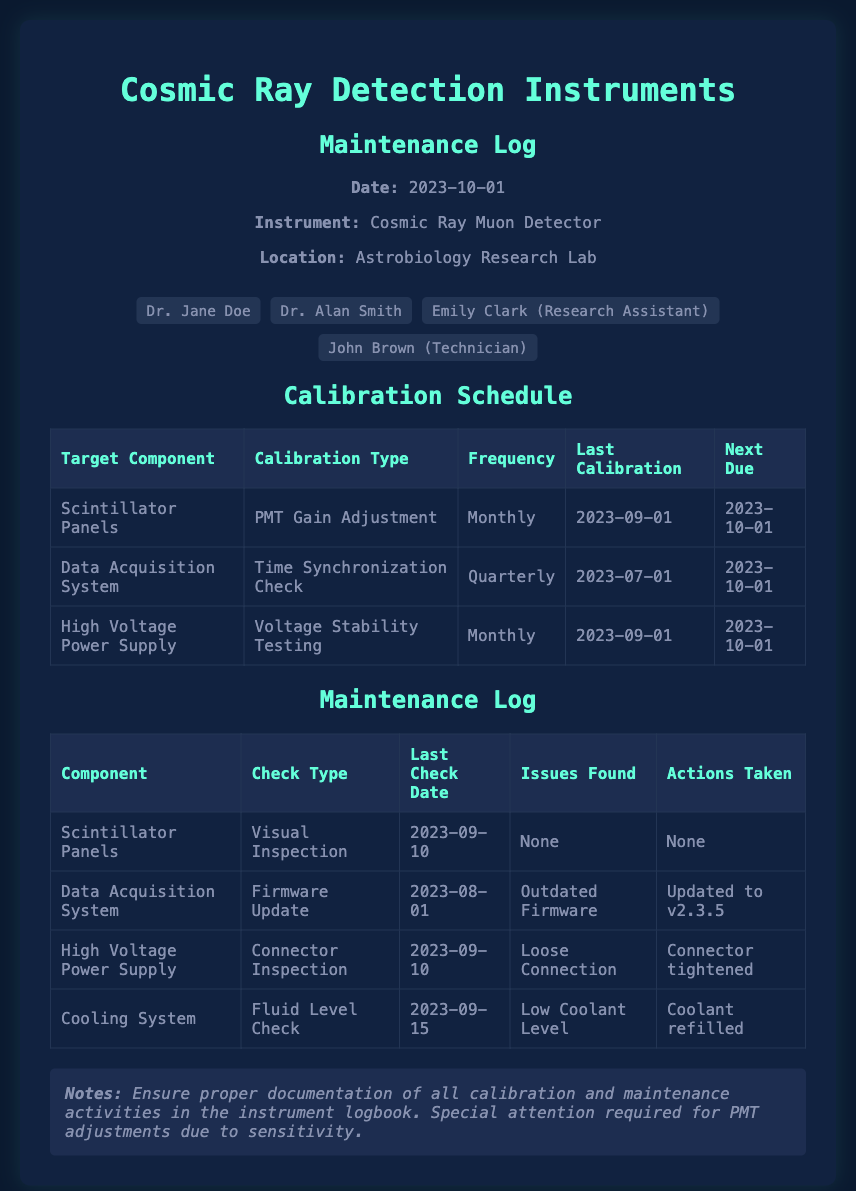what is the date of the maintenance log? The date of the maintenance log is explicitly mentioned at the top of the document.
Answer: 2023-10-01 who is the technician listed in the team member section? The team member section includes a specific reference to the technician.
Answer: John Brown when was the last calibration for the High Voltage Power Supply? The last calibration date for the High Voltage Power Supply is provided in the calibration schedule.
Answer: 2023-09-01 what issue was found during the firmware update check? The maintenance log details the issues noted for each component after checks, specifically for the Data Acquisition System.
Answer: Outdated Firmware how often are the Scintillator Panels calibrated? The frequency of calibration for the Scintillator Panels is stated in the calibration schedule.
Answer: Monthly what action was taken for the loose connection found in the High Voltage Power Supply? The actions taken for issues found are listed in the maintenance log regarding the High Voltage Power Supply.
Answer: Connector tightened what is the next due date for the Data Acquisition System's calibration? The next due date for the calibration of the Data Acquisition System is provided in the calibration schedule.
Answer: 2023-10-01 what was the last check type performed on the Cooling System? The maintenance log indicates the type of check performed on each component, including the Cooling System.
Answer: Fluid Level Check what special attention is required during calibration? The notes section provides insights on specific considerations during calibration.
Answer: PMT adjustments 